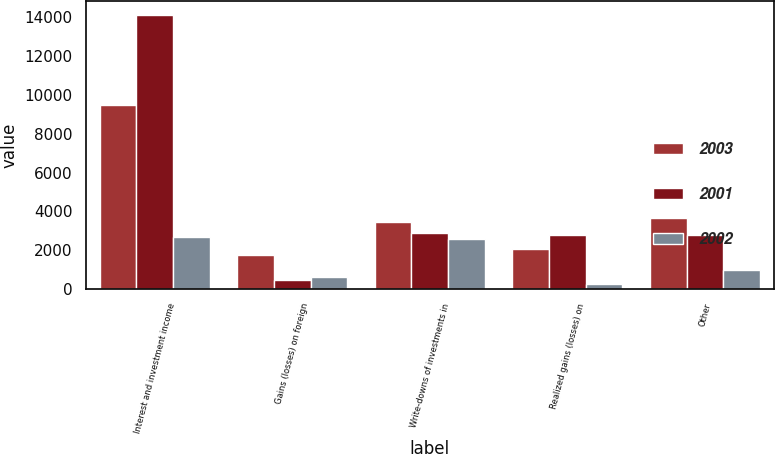<chart> <loc_0><loc_0><loc_500><loc_500><stacked_bar_chart><ecel><fcel>Interest and investment income<fcel>Gains (losses) on foreign<fcel>Write-downs of investments in<fcel>Realized gains (losses) on<fcel>Other<nl><fcel>2003<fcel>9466<fcel>1727<fcel>3436<fcel>2069<fcel>3678<nl><fcel>2001<fcel>14144<fcel>440<fcel>2861<fcel>2775<fcel>2783<nl><fcel>2002<fcel>2664<fcel>628<fcel>2553<fcel>263<fcel>983<nl></chart> 